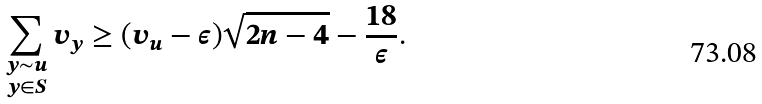<formula> <loc_0><loc_0><loc_500><loc_500>\sum _ { \substack { y \sim u \\ y \in S } } v _ { y } \geq ( v _ { u } - \epsilon ) \sqrt { 2 n - 4 } - \frac { 1 8 } { \epsilon } .</formula> 